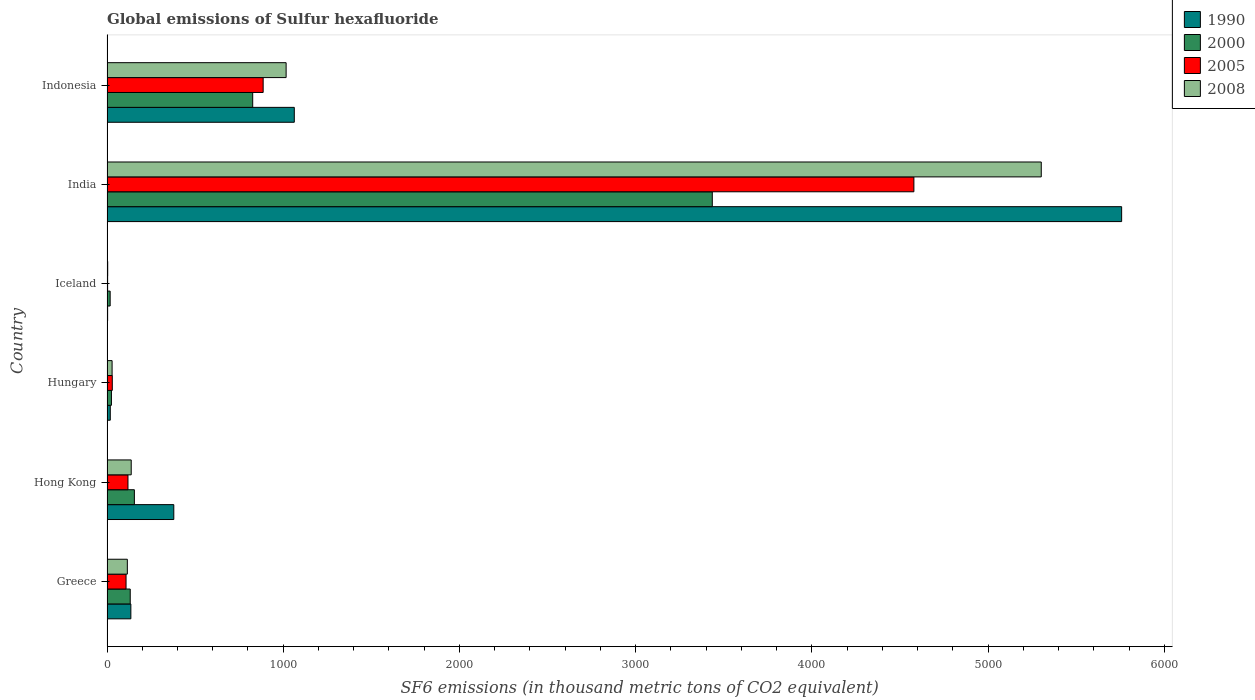How many different coloured bars are there?
Offer a terse response. 4. Are the number of bars on each tick of the Y-axis equal?
Your answer should be very brief. Yes. How many bars are there on the 6th tick from the top?
Your answer should be compact. 4. How many bars are there on the 4th tick from the bottom?
Make the answer very short. 4. What is the label of the 4th group of bars from the top?
Provide a short and direct response. Hungary. In how many cases, is the number of bars for a given country not equal to the number of legend labels?
Offer a very short reply. 0. What is the global emissions of Sulfur hexafluoride in 1990 in Greece?
Offer a very short reply. 135.4. Across all countries, what is the maximum global emissions of Sulfur hexafluoride in 2008?
Make the answer very short. 5301.4. What is the total global emissions of Sulfur hexafluoride in 2000 in the graph?
Provide a short and direct response. 4591.7. What is the difference between the global emissions of Sulfur hexafluoride in 2000 in Greece and that in Hong Kong?
Ensure brevity in your answer.  -23.5. What is the difference between the global emissions of Sulfur hexafluoride in 2000 in Hungary and the global emissions of Sulfur hexafluoride in 2005 in Iceland?
Give a very brief answer. 21.7. What is the average global emissions of Sulfur hexafluoride in 2008 per country?
Your answer should be very brief. 1100.58. What is the difference between the global emissions of Sulfur hexafluoride in 1990 and global emissions of Sulfur hexafluoride in 2008 in Hungary?
Your answer should be compact. -10.3. In how many countries, is the global emissions of Sulfur hexafluoride in 2000 greater than 2200 thousand metric tons?
Your response must be concise. 1. What is the ratio of the global emissions of Sulfur hexafluoride in 2005 in Hungary to that in India?
Keep it short and to the point. 0.01. Is the global emissions of Sulfur hexafluoride in 1990 in Hungary less than that in India?
Offer a terse response. Yes. Is the difference between the global emissions of Sulfur hexafluoride in 1990 in Greece and Hong Kong greater than the difference between the global emissions of Sulfur hexafluoride in 2008 in Greece and Hong Kong?
Offer a very short reply. No. What is the difference between the highest and the second highest global emissions of Sulfur hexafluoride in 2008?
Provide a short and direct response. 4285. What is the difference between the highest and the lowest global emissions of Sulfur hexafluoride in 1990?
Your response must be concise. 5754. Is the sum of the global emissions of Sulfur hexafluoride in 2000 in Greece and India greater than the maximum global emissions of Sulfur hexafluoride in 1990 across all countries?
Your answer should be compact. No. Is it the case that in every country, the sum of the global emissions of Sulfur hexafluoride in 2005 and global emissions of Sulfur hexafluoride in 2000 is greater than the global emissions of Sulfur hexafluoride in 1990?
Offer a very short reply. No. How many bars are there?
Give a very brief answer. 24. Are all the bars in the graph horizontal?
Ensure brevity in your answer.  Yes. Are the values on the major ticks of X-axis written in scientific E-notation?
Keep it short and to the point. No. Where does the legend appear in the graph?
Your answer should be very brief. Top right. How many legend labels are there?
Ensure brevity in your answer.  4. How are the legend labels stacked?
Give a very brief answer. Vertical. What is the title of the graph?
Keep it short and to the point. Global emissions of Sulfur hexafluoride. What is the label or title of the X-axis?
Give a very brief answer. SF6 emissions (in thousand metric tons of CO2 equivalent). What is the SF6 emissions (in thousand metric tons of CO2 equivalent) of 1990 in Greece?
Your answer should be very brief. 135.4. What is the SF6 emissions (in thousand metric tons of CO2 equivalent) in 2000 in Greece?
Ensure brevity in your answer.  131.8. What is the SF6 emissions (in thousand metric tons of CO2 equivalent) of 2005 in Greece?
Provide a short and direct response. 108.1. What is the SF6 emissions (in thousand metric tons of CO2 equivalent) in 2008 in Greece?
Make the answer very short. 115.4. What is the SF6 emissions (in thousand metric tons of CO2 equivalent) of 1990 in Hong Kong?
Keep it short and to the point. 379. What is the SF6 emissions (in thousand metric tons of CO2 equivalent) in 2000 in Hong Kong?
Make the answer very short. 155.3. What is the SF6 emissions (in thousand metric tons of CO2 equivalent) in 2005 in Hong Kong?
Your answer should be compact. 119. What is the SF6 emissions (in thousand metric tons of CO2 equivalent) of 2008 in Hong Kong?
Provide a short and direct response. 137.4. What is the SF6 emissions (in thousand metric tons of CO2 equivalent) of 1990 in Hungary?
Your response must be concise. 18.6. What is the SF6 emissions (in thousand metric tons of CO2 equivalent) of 2000 in Hungary?
Give a very brief answer. 25.2. What is the SF6 emissions (in thousand metric tons of CO2 equivalent) of 2005 in Hungary?
Offer a terse response. 30. What is the SF6 emissions (in thousand metric tons of CO2 equivalent) of 2008 in Hungary?
Your answer should be very brief. 28.9. What is the SF6 emissions (in thousand metric tons of CO2 equivalent) in 1990 in India?
Ensure brevity in your answer.  5757.5. What is the SF6 emissions (in thousand metric tons of CO2 equivalent) of 2000 in India?
Make the answer very short. 3434.7. What is the SF6 emissions (in thousand metric tons of CO2 equivalent) of 2005 in India?
Provide a short and direct response. 4578.7. What is the SF6 emissions (in thousand metric tons of CO2 equivalent) in 2008 in India?
Give a very brief answer. 5301.4. What is the SF6 emissions (in thousand metric tons of CO2 equivalent) in 1990 in Indonesia?
Give a very brief answer. 1062.8. What is the SF6 emissions (in thousand metric tons of CO2 equivalent) in 2000 in Indonesia?
Keep it short and to the point. 826.8. What is the SF6 emissions (in thousand metric tons of CO2 equivalent) in 2005 in Indonesia?
Ensure brevity in your answer.  886.1. What is the SF6 emissions (in thousand metric tons of CO2 equivalent) in 2008 in Indonesia?
Provide a short and direct response. 1016.4. Across all countries, what is the maximum SF6 emissions (in thousand metric tons of CO2 equivalent) of 1990?
Provide a succinct answer. 5757.5. Across all countries, what is the maximum SF6 emissions (in thousand metric tons of CO2 equivalent) of 2000?
Make the answer very short. 3434.7. Across all countries, what is the maximum SF6 emissions (in thousand metric tons of CO2 equivalent) of 2005?
Offer a terse response. 4578.7. Across all countries, what is the maximum SF6 emissions (in thousand metric tons of CO2 equivalent) of 2008?
Provide a succinct answer. 5301.4. Across all countries, what is the minimum SF6 emissions (in thousand metric tons of CO2 equivalent) in 1990?
Offer a terse response. 3.5. Across all countries, what is the minimum SF6 emissions (in thousand metric tons of CO2 equivalent) in 2000?
Offer a terse response. 17.9. Across all countries, what is the minimum SF6 emissions (in thousand metric tons of CO2 equivalent) of 2005?
Make the answer very short. 3.5. What is the total SF6 emissions (in thousand metric tons of CO2 equivalent) of 1990 in the graph?
Provide a short and direct response. 7356.8. What is the total SF6 emissions (in thousand metric tons of CO2 equivalent) in 2000 in the graph?
Your answer should be very brief. 4591.7. What is the total SF6 emissions (in thousand metric tons of CO2 equivalent) in 2005 in the graph?
Offer a terse response. 5725.4. What is the total SF6 emissions (in thousand metric tons of CO2 equivalent) of 2008 in the graph?
Ensure brevity in your answer.  6603.5. What is the difference between the SF6 emissions (in thousand metric tons of CO2 equivalent) in 1990 in Greece and that in Hong Kong?
Make the answer very short. -243.6. What is the difference between the SF6 emissions (in thousand metric tons of CO2 equivalent) in 2000 in Greece and that in Hong Kong?
Ensure brevity in your answer.  -23.5. What is the difference between the SF6 emissions (in thousand metric tons of CO2 equivalent) of 2005 in Greece and that in Hong Kong?
Offer a very short reply. -10.9. What is the difference between the SF6 emissions (in thousand metric tons of CO2 equivalent) in 1990 in Greece and that in Hungary?
Your answer should be compact. 116.8. What is the difference between the SF6 emissions (in thousand metric tons of CO2 equivalent) of 2000 in Greece and that in Hungary?
Provide a short and direct response. 106.6. What is the difference between the SF6 emissions (in thousand metric tons of CO2 equivalent) in 2005 in Greece and that in Hungary?
Your answer should be compact. 78.1. What is the difference between the SF6 emissions (in thousand metric tons of CO2 equivalent) of 2008 in Greece and that in Hungary?
Keep it short and to the point. 86.5. What is the difference between the SF6 emissions (in thousand metric tons of CO2 equivalent) of 1990 in Greece and that in Iceland?
Provide a succinct answer. 131.9. What is the difference between the SF6 emissions (in thousand metric tons of CO2 equivalent) of 2000 in Greece and that in Iceland?
Offer a terse response. 113.9. What is the difference between the SF6 emissions (in thousand metric tons of CO2 equivalent) in 2005 in Greece and that in Iceland?
Ensure brevity in your answer.  104.6. What is the difference between the SF6 emissions (in thousand metric tons of CO2 equivalent) in 2008 in Greece and that in Iceland?
Offer a very short reply. 111.4. What is the difference between the SF6 emissions (in thousand metric tons of CO2 equivalent) in 1990 in Greece and that in India?
Make the answer very short. -5622.1. What is the difference between the SF6 emissions (in thousand metric tons of CO2 equivalent) in 2000 in Greece and that in India?
Your response must be concise. -3302.9. What is the difference between the SF6 emissions (in thousand metric tons of CO2 equivalent) in 2005 in Greece and that in India?
Your answer should be compact. -4470.6. What is the difference between the SF6 emissions (in thousand metric tons of CO2 equivalent) in 2008 in Greece and that in India?
Your answer should be very brief. -5186. What is the difference between the SF6 emissions (in thousand metric tons of CO2 equivalent) of 1990 in Greece and that in Indonesia?
Ensure brevity in your answer.  -927.4. What is the difference between the SF6 emissions (in thousand metric tons of CO2 equivalent) in 2000 in Greece and that in Indonesia?
Your response must be concise. -695. What is the difference between the SF6 emissions (in thousand metric tons of CO2 equivalent) in 2005 in Greece and that in Indonesia?
Make the answer very short. -778. What is the difference between the SF6 emissions (in thousand metric tons of CO2 equivalent) in 2008 in Greece and that in Indonesia?
Ensure brevity in your answer.  -901. What is the difference between the SF6 emissions (in thousand metric tons of CO2 equivalent) of 1990 in Hong Kong and that in Hungary?
Your answer should be compact. 360.4. What is the difference between the SF6 emissions (in thousand metric tons of CO2 equivalent) in 2000 in Hong Kong and that in Hungary?
Offer a very short reply. 130.1. What is the difference between the SF6 emissions (in thousand metric tons of CO2 equivalent) in 2005 in Hong Kong and that in Hungary?
Your answer should be very brief. 89. What is the difference between the SF6 emissions (in thousand metric tons of CO2 equivalent) of 2008 in Hong Kong and that in Hungary?
Your answer should be very brief. 108.5. What is the difference between the SF6 emissions (in thousand metric tons of CO2 equivalent) in 1990 in Hong Kong and that in Iceland?
Offer a terse response. 375.5. What is the difference between the SF6 emissions (in thousand metric tons of CO2 equivalent) of 2000 in Hong Kong and that in Iceland?
Offer a terse response. 137.4. What is the difference between the SF6 emissions (in thousand metric tons of CO2 equivalent) of 2005 in Hong Kong and that in Iceland?
Ensure brevity in your answer.  115.5. What is the difference between the SF6 emissions (in thousand metric tons of CO2 equivalent) in 2008 in Hong Kong and that in Iceland?
Make the answer very short. 133.4. What is the difference between the SF6 emissions (in thousand metric tons of CO2 equivalent) of 1990 in Hong Kong and that in India?
Your answer should be compact. -5378.5. What is the difference between the SF6 emissions (in thousand metric tons of CO2 equivalent) of 2000 in Hong Kong and that in India?
Make the answer very short. -3279.4. What is the difference between the SF6 emissions (in thousand metric tons of CO2 equivalent) in 2005 in Hong Kong and that in India?
Your answer should be compact. -4459.7. What is the difference between the SF6 emissions (in thousand metric tons of CO2 equivalent) of 2008 in Hong Kong and that in India?
Give a very brief answer. -5164. What is the difference between the SF6 emissions (in thousand metric tons of CO2 equivalent) of 1990 in Hong Kong and that in Indonesia?
Your response must be concise. -683.8. What is the difference between the SF6 emissions (in thousand metric tons of CO2 equivalent) in 2000 in Hong Kong and that in Indonesia?
Provide a succinct answer. -671.5. What is the difference between the SF6 emissions (in thousand metric tons of CO2 equivalent) of 2005 in Hong Kong and that in Indonesia?
Ensure brevity in your answer.  -767.1. What is the difference between the SF6 emissions (in thousand metric tons of CO2 equivalent) in 2008 in Hong Kong and that in Indonesia?
Provide a short and direct response. -879. What is the difference between the SF6 emissions (in thousand metric tons of CO2 equivalent) in 2000 in Hungary and that in Iceland?
Ensure brevity in your answer.  7.3. What is the difference between the SF6 emissions (in thousand metric tons of CO2 equivalent) of 2005 in Hungary and that in Iceland?
Make the answer very short. 26.5. What is the difference between the SF6 emissions (in thousand metric tons of CO2 equivalent) in 2008 in Hungary and that in Iceland?
Offer a terse response. 24.9. What is the difference between the SF6 emissions (in thousand metric tons of CO2 equivalent) in 1990 in Hungary and that in India?
Make the answer very short. -5738.9. What is the difference between the SF6 emissions (in thousand metric tons of CO2 equivalent) in 2000 in Hungary and that in India?
Keep it short and to the point. -3409.5. What is the difference between the SF6 emissions (in thousand metric tons of CO2 equivalent) in 2005 in Hungary and that in India?
Your answer should be compact. -4548.7. What is the difference between the SF6 emissions (in thousand metric tons of CO2 equivalent) of 2008 in Hungary and that in India?
Your answer should be very brief. -5272.5. What is the difference between the SF6 emissions (in thousand metric tons of CO2 equivalent) in 1990 in Hungary and that in Indonesia?
Your response must be concise. -1044.2. What is the difference between the SF6 emissions (in thousand metric tons of CO2 equivalent) in 2000 in Hungary and that in Indonesia?
Your answer should be compact. -801.6. What is the difference between the SF6 emissions (in thousand metric tons of CO2 equivalent) of 2005 in Hungary and that in Indonesia?
Keep it short and to the point. -856.1. What is the difference between the SF6 emissions (in thousand metric tons of CO2 equivalent) in 2008 in Hungary and that in Indonesia?
Keep it short and to the point. -987.5. What is the difference between the SF6 emissions (in thousand metric tons of CO2 equivalent) in 1990 in Iceland and that in India?
Keep it short and to the point. -5754. What is the difference between the SF6 emissions (in thousand metric tons of CO2 equivalent) of 2000 in Iceland and that in India?
Provide a succinct answer. -3416.8. What is the difference between the SF6 emissions (in thousand metric tons of CO2 equivalent) of 2005 in Iceland and that in India?
Offer a very short reply. -4575.2. What is the difference between the SF6 emissions (in thousand metric tons of CO2 equivalent) in 2008 in Iceland and that in India?
Keep it short and to the point. -5297.4. What is the difference between the SF6 emissions (in thousand metric tons of CO2 equivalent) in 1990 in Iceland and that in Indonesia?
Keep it short and to the point. -1059.3. What is the difference between the SF6 emissions (in thousand metric tons of CO2 equivalent) in 2000 in Iceland and that in Indonesia?
Keep it short and to the point. -808.9. What is the difference between the SF6 emissions (in thousand metric tons of CO2 equivalent) of 2005 in Iceland and that in Indonesia?
Offer a terse response. -882.6. What is the difference between the SF6 emissions (in thousand metric tons of CO2 equivalent) of 2008 in Iceland and that in Indonesia?
Your answer should be very brief. -1012.4. What is the difference between the SF6 emissions (in thousand metric tons of CO2 equivalent) in 1990 in India and that in Indonesia?
Keep it short and to the point. 4694.7. What is the difference between the SF6 emissions (in thousand metric tons of CO2 equivalent) of 2000 in India and that in Indonesia?
Offer a very short reply. 2607.9. What is the difference between the SF6 emissions (in thousand metric tons of CO2 equivalent) of 2005 in India and that in Indonesia?
Make the answer very short. 3692.6. What is the difference between the SF6 emissions (in thousand metric tons of CO2 equivalent) in 2008 in India and that in Indonesia?
Offer a very short reply. 4285. What is the difference between the SF6 emissions (in thousand metric tons of CO2 equivalent) in 1990 in Greece and the SF6 emissions (in thousand metric tons of CO2 equivalent) in 2000 in Hong Kong?
Keep it short and to the point. -19.9. What is the difference between the SF6 emissions (in thousand metric tons of CO2 equivalent) in 1990 in Greece and the SF6 emissions (in thousand metric tons of CO2 equivalent) in 2008 in Hong Kong?
Make the answer very short. -2. What is the difference between the SF6 emissions (in thousand metric tons of CO2 equivalent) of 2000 in Greece and the SF6 emissions (in thousand metric tons of CO2 equivalent) of 2005 in Hong Kong?
Your answer should be compact. 12.8. What is the difference between the SF6 emissions (in thousand metric tons of CO2 equivalent) of 2000 in Greece and the SF6 emissions (in thousand metric tons of CO2 equivalent) of 2008 in Hong Kong?
Provide a succinct answer. -5.6. What is the difference between the SF6 emissions (in thousand metric tons of CO2 equivalent) in 2005 in Greece and the SF6 emissions (in thousand metric tons of CO2 equivalent) in 2008 in Hong Kong?
Your answer should be compact. -29.3. What is the difference between the SF6 emissions (in thousand metric tons of CO2 equivalent) of 1990 in Greece and the SF6 emissions (in thousand metric tons of CO2 equivalent) of 2000 in Hungary?
Offer a terse response. 110.2. What is the difference between the SF6 emissions (in thousand metric tons of CO2 equivalent) in 1990 in Greece and the SF6 emissions (in thousand metric tons of CO2 equivalent) in 2005 in Hungary?
Offer a terse response. 105.4. What is the difference between the SF6 emissions (in thousand metric tons of CO2 equivalent) in 1990 in Greece and the SF6 emissions (in thousand metric tons of CO2 equivalent) in 2008 in Hungary?
Provide a short and direct response. 106.5. What is the difference between the SF6 emissions (in thousand metric tons of CO2 equivalent) of 2000 in Greece and the SF6 emissions (in thousand metric tons of CO2 equivalent) of 2005 in Hungary?
Keep it short and to the point. 101.8. What is the difference between the SF6 emissions (in thousand metric tons of CO2 equivalent) in 2000 in Greece and the SF6 emissions (in thousand metric tons of CO2 equivalent) in 2008 in Hungary?
Ensure brevity in your answer.  102.9. What is the difference between the SF6 emissions (in thousand metric tons of CO2 equivalent) of 2005 in Greece and the SF6 emissions (in thousand metric tons of CO2 equivalent) of 2008 in Hungary?
Make the answer very short. 79.2. What is the difference between the SF6 emissions (in thousand metric tons of CO2 equivalent) in 1990 in Greece and the SF6 emissions (in thousand metric tons of CO2 equivalent) in 2000 in Iceland?
Your answer should be very brief. 117.5. What is the difference between the SF6 emissions (in thousand metric tons of CO2 equivalent) in 1990 in Greece and the SF6 emissions (in thousand metric tons of CO2 equivalent) in 2005 in Iceland?
Offer a very short reply. 131.9. What is the difference between the SF6 emissions (in thousand metric tons of CO2 equivalent) of 1990 in Greece and the SF6 emissions (in thousand metric tons of CO2 equivalent) of 2008 in Iceland?
Your answer should be very brief. 131.4. What is the difference between the SF6 emissions (in thousand metric tons of CO2 equivalent) of 2000 in Greece and the SF6 emissions (in thousand metric tons of CO2 equivalent) of 2005 in Iceland?
Your response must be concise. 128.3. What is the difference between the SF6 emissions (in thousand metric tons of CO2 equivalent) of 2000 in Greece and the SF6 emissions (in thousand metric tons of CO2 equivalent) of 2008 in Iceland?
Your response must be concise. 127.8. What is the difference between the SF6 emissions (in thousand metric tons of CO2 equivalent) in 2005 in Greece and the SF6 emissions (in thousand metric tons of CO2 equivalent) in 2008 in Iceland?
Your response must be concise. 104.1. What is the difference between the SF6 emissions (in thousand metric tons of CO2 equivalent) of 1990 in Greece and the SF6 emissions (in thousand metric tons of CO2 equivalent) of 2000 in India?
Your response must be concise. -3299.3. What is the difference between the SF6 emissions (in thousand metric tons of CO2 equivalent) in 1990 in Greece and the SF6 emissions (in thousand metric tons of CO2 equivalent) in 2005 in India?
Keep it short and to the point. -4443.3. What is the difference between the SF6 emissions (in thousand metric tons of CO2 equivalent) of 1990 in Greece and the SF6 emissions (in thousand metric tons of CO2 equivalent) of 2008 in India?
Your answer should be compact. -5166. What is the difference between the SF6 emissions (in thousand metric tons of CO2 equivalent) of 2000 in Greece and the SF6 emissions (in thousand metric tons of CO2 equivalent) of 2005 in India?
Your response must be concise. -4446.9. What is the difference between the SF6 emissions (in thousand metric tons of CO2 equivalent) of 2000 in Greece and the SF6 emissions (in thousand metric tons of CO2 equivalent) of 2008 in India?
Keep it short and to the point. -5169.6. What is the difference between the SF6 emissions (in thousand metric tons of CO2 equivalent) of 2005 in Greece and the SF6 emissions (in thousand metric tons of CO2 equivalent) of 2008 in India?
Give a very brief answer. -5193.3. What is the difference between the SF6 emissions (in thousand metric tons of CO2 equivalent) of 1990 in Greece and the SF6 emissions (in thousand metric tons of CO2 equivalent) of 2000 in Indonesia?
Ensure brevity in your answer.  -691.4. What is the difference between the SF6 emissions (in thousand metric tons of CO2 equivalent) in 1990 in Greece and the SF6 emissions (in thousand metric tons of CO2 equivalent) in 2005 in Indonesia?
Give a very brief answer. -750.7. What is the difference between the SF6 emissions (in thousand metric tons of CO2 equivalent) in 1990 in Greece and the SF6 emissions (in thousand metric tons of CO2 equivalent) in 2008 in Indonesia?
Your answer should be very brief. -881. What is the difference between the SF6 emissions (in thousand metric tons of CO2 equivalent) of 2000 in Greece and the SF6 emissions (in thousand metric tons of CO2 equivalent) of 2005 in Indonesia?
Keep it short and to the point. -754.3. What is the difference between the SF6 emissions (in thousand metric tons of CO2 equivalent) in 2000 in Greece and the SF6 emissions (in thousand metric tons of CO2 equivalent) in 2008 in Indonesia?
Your answer should be very brief. -884.6. What is the difference between the SF6 emissions (in thousand metric tons of CO2 equivalent) of 2005 in Greece and the SF6 emissions (in thousand metric tons of CO2 equivalent) of 2008 in Indonesia?
Offer a terse response. -908.3. What is the difference between the SF6 emissions (in thousand metric tons of CO2 equivalent) of 1990 in Hong Kong and the SF6 emissions (in thousand metric tons of CO2 equivalent) of 2000 in Hungary?
Give a very brief answer. 353.8. What is the difference between the SF6 emissions (in thousand metric tons of CO2 equivalent) in 1990 in Hong Kong and the SF6 emissions (in thousand metric tons of CO2 equivalent) in 2005 in Hungary?
Your answer should be compact. 349. What is the difference between the SF6 emissions (in thousand metric tons of CO2 equivalent) of 1990 in Hong Kong and the SF6 emissions (in thousand metric tons of CO2 equivalent) of 2008 in Hungary?
Your answer should be compact. 350.1. What is the difference between the SF6 emissions (in thousand metric tons of CO2 equivalent) of 2000 in Hong Kong and the SF6 emissions (in thousand metric tons of CO2 equivalent) of 2005 in Hungary?
Give a very brief answer. 125.3. What is the difference between the SF6 emissions (in thousand metric tons of CO2 equivalent) of 2000 in Hong Kong and the SF6 emissions (in thousand metric tons of CO2 equivalent) of 2008 in Hungary?
Keep it short and to the point. 126.4. What is the difference between the SF6 emissions (in thousand metric tons of CO2 equivalent) of 2005 in Hong Kong and the SF6 emissions (in thousand metric tons of CO2 equivalent) of 2008 in Hungary?
Give a very brief answer. 90.1. What is the difference between the SF6 emissions (in thousand metric tons of CO2 equivalent) in 1990 in Hong Kong and the SF6 emissions (in thousand metric tons of CO2 equivalent) in 2000 in Iceland?
Provide a succinct answer. 361.1. What is the difference between the SF6 emissions (in thousand metric tons of CO2 equivalent) in 1990 in Hong Kong and the SF6 emissions (in thousand metric tons of CO2 equivalent) in 2005 in Iceland?
Ensure brevity in your answer.  375.5. What is the difference between the SF6 emissions (in thousand metric tons of CO2 equivalent) of 1990 in Hong Kong and the SF6 emissions (in thousand metric tons of CO2 equivalent) of 2008 in Iceland?
Your answer should be compact. 375. What is the difference between the SF6 emissions (in thousand metric tons of CO2 equivalent) in 2000 in Hong Kong and the SF6 emissions (in thousand metric tons of CO2 equivalent) in 2005 in Iceland?
Provide a short and direct response. 151.8. What is the difference between the SF6 emissions (in thousand metric tons of CO2 equivalent) in 2000 in Hong Kong and the SF6 emissions (in thousand metric tons of CO2 equivalent) in 2008 in Iceland?
Provide a short and direct response. 151.3. What is the difference between the SF6 emissions (in thousand metric tons of CO2 equivalent) in 2005 in Hong Kong and the SF6 emissions (in thousand metric tons of CO2 equivalent) in 2008 in Iceland?
Your answer should be very brief. 115. What is the difference between the SF6 emissions (in thousand metric tons of CO2 equivalent) of 1990 in Hong Kong and the SF6 emissions (in thousand metric tons of CO2 equivalent) of 2000 in India?
Keep it short and to the point. -3055.7. What is the difference between the SF6 emissions (in thousand metric tons of CO2 equivalent) of 1990 in Hong Kong and the SF6 emissions (in thousand metric tons of CO2 equivalent) of 2005 in India?
Keep it short and to the point. -4199.7. What is the difference between the SF6 emissions (in thousand metric tons of CO2 equivalent) of 1990 in Hong Kong and the SF6 emissions (in thousand metric tons of CO2 equivalent) of 2008 in India?
Ensure brevity in your answer.  -4922.4. What is the difference between the SF6 emissions (in thousand metric tons of CO2 equivalent) of 2000 in Hong Kong and the SF6 emissions (in thousand metric tons of CO2 equivalent) of 2005 in India?
Your answer should be very brief. -4423.4. What is the difference between the SF6 emissions (in thousand metric tons of CO2 equivalent) of 2000 in Hong Kong and the SF6 emissions (in thousand metric tons of CO2 equivalent) of 2008 in India?
Provide a succinct answer. -5146.1. What is the difference between the SF6 emissions (in thousand metric tons of CO2 equivalent) of 2005 in Hong Kong and the SF6 emissions (in thousand metric tons of CO2 equivalent) of 2008 in India?
Offer a very short reply. -5182.4. What is the difference between the SF6 emissions (in thousand metric tons of CO2 equivalent) of 1990 in Hong Kong and the SF6 emissions (in thousand metric tons of CO2 equivalent) of 2000 in Indonesia?
Give a very brief answer. -447.8. What is the difference between the SF6 emissions (in thousand metric tons of CO2 equivalent) in 1990 in Hong Kong and the SF6 emissions (in thousand metric tons of CO2 equivalent) in 2005 in Indonesia?
Give a very brief answer. -507.1. What is the difference between the SF6 emissions (in thousand metric tons of CO2 equivalent) in 1990 in Hong Kong and the SF6 emissions (in thousand metric tons of CO2 equivalent) in 2008 in Indonesia?
Offer a terse response. -637.4. What is the difference between the SF6 emissions (in thousand metric tons of CO2 equivalent) of 2000 in Hong Kong and the SF6 emissions (in thousand metric tons of CO2 equivalent) of 2005 in Indonesia?
Offer a terse response. -730.8. What is the difference between the SF6 emissions (in thousand metric tons of CO2 equivalent) in 2000 in Hong Kong and the SF6 emissions (in thousand metric tons of CO2 equivalent) in 2008 in Indonesia?
Provide a succinct answer. -861.1. What is the difference between the SF6 emissions (in thousand metric tons of CO2 equivalent) of 2005 in Hong Kong and the SF6 emissions (in thousand metric tons of CO2 equivalent) of 2008 in Indonesia?
Your answer should be very brief. -897.4. What is the difference between the SF6 emissions (in thousand metric tons of CO2 equivalent) in 1990 in Hungary and the SF6 emissions (in thousand metric tons of CO2 equivalent) in 2005 in Iceland?
Offer a very short reply. 15.1. What is the difference between the SF6 emissions (in thousand metric tons of CO2 equivalent) in 2000 in Hungary and the SF6 emissions (in thousand metric tons of CO2 equivalent) in 2005 in Iceland?
Offer a terse response. 21.7. What is the difference between the SF6 emissions (in thousand metric tons of CO2 equivalent) in 2000 in Hungary and the SF6 emissions (in thousand metric tons of CO2 equivalent) in 2008 in Iceland?
Your answer should be compact. 21.2. What is the difference between the SF6 emissions (in thousand metric tons of CO2 equivalent) of 1990 in Hungary and the SF6 emissions (in thousand metric tons of CO2 equivalent) of 2000 in India?
Ensure brevity in your answer.  -3416.1. What is the difference between the SF6 emissions (in thousand metric tons of CO2 equivalent) in 1990 in Hungary and the SF6 emissions (in thousand metric tons of CO2 equivalent) in 2005 in India?
Your answer should be compact. -4560.1. What is the difference between the SF6 emissions (in thousand metric tons of CO2 equivalent) in 1990 in Hungary and the SF6 emissions (in thousand metric tons of CO2 equivalent) in 2008 in India?
Offer a very short reply. -5282.8. What is the difference between the SF6 emissions (in thousand metric tons of CO2 equivalent) in 2000 in Hungary and the SF6 emissions (in thousand metric tons of CO2 equivalent) in 2005 in India?
Provide a succinct answer. -4553.5. What is the difference between the SF6 emissions (in thousand metric tons of CO2 equivalent) of 2000 in Hungary and the SF6 emissions (in thousand metric tons of CO2 equivalent) of 2008 in India?
Keep it short and to the point. -5276.2. What is the difference between the SF6 emissions (in thousand metric tons of CO2 equivalent) of 2005 in Hungary and the SF6 emissions (in thousand metric tons of CO2 equivalent) of 2008 in India?
Offer a terse response. -5271.4. What is the difference between the SF6 emissions (in thousand metric tons of CO2 equivalent) in 1990 in Hungary and the SF6 emissions (in thousand metric tons of CO2 equivalent) in 2000 in Indonesia?
Keep it short and to the point. -808.2. What is the difference between the SF6 emissions (in thousand metric tons of CO2 equivalent) of 1990 in Hungary and the SF6 emissions (in thousand metric tons of CO2 equivalent) of 2005 in Indonesia?
Your response must be concise. -867.5. What is the difference between the SF6 emissions (in thousand metric tons of CO2 equivalent) of 1990 in Hungary and the SF6 emissions (in thousand metric tons of CO2 equivalent) of 2008 in Indonesia?
Offer a very short reply. -997.8. What is the difference between the SF6 emissions (in thousand metric tons of CO2 equivalent) in 2000 in Hungary and the SF6 emissions (in thousand metric tons of CO2 equivalent) in 2005 in Indonesia?
Your answer should be very brief. -860.9. What is the difference between the SF6 emissions (in thousand metric tons of CO2 equivalent) of 2000 in Hungary and the SF6 emissions (in thousand metric tons of CO2 equivalent) of 2008 in Indonesia?
Your answer should be very brief. -991.2. What is the difference between the SF6 emissions (in thousand metric tons of CO2 equivalent) in 2005 in Hungary and the SF6 emissions (in thousand metric tons of CO2 equivalent) in 2008 in Indonesia?
Offer a terse response. -986.4. What is the difference between the SF6 emissions (in thousand metric tons of CO2 equivalent) in 1990 in Iceland and the SF6 emissions (in thousand metric tons of CO2 equivalent) in 2000 in India?
Make the answer very short. -3431.2. What is the difference between the SF6 emissions (in thousand metric tons of CO2 equivalent) in 1990 in Iceland and the SF6 emissions (in thousand metric tons of CO2 equivalent) in 2005 in India?
Ensure brevity in your answer.  -4575.2. What is the difference between the SF6 emissions (in thousand metric tons of CO2 equivalent) in 1990 in Iceland and the SF6 emissions (in thousand metric tons of CO2 equivalent) in 2008 in India?
Your answer should be very brief. -5297.9. What is the difference between the SF6 emissions (in thousand metric tons of CO2 equivalent) in 2000 in Iceland and the SF6 emissions (in thousand metric tons of CO2 equivalent) in 2005 in India?
Provide a short and direct response. -4560.8. What is the difference between the SF6 emissions (in thousand metric tons of CO2 equivalent) of 2000 in Iceland and the SF6 emissions (in thousand metric tons of CO2 equivalent) of 2008 in India?
Offer a terse response. -5283.5. What is the difference between the SF6 emissions (in thousand metric tons of CO2 equivalent) of 2005 in Iceland and the SF6 emissions (in thousand metric tons of CO2 equivalent) of 2008 in India?
Ensure brevity in your answer.  -5297.9. What is the difference between the SF6 emissions (in thousand metric tons of CO2 equivalent) in 1990 in Iceland and the SF6 emissions (in thousand metric tons of CO2 equivalent) in 2000 in Indonesia?
Provide a succinct answer. -823.3. What is the difference between the SF6 emissions (in thousand metric tons of CO2 equivalent) in 1990 in Iceland and the SF6 emissions (in thousand metric tons of CO2 equivalent) in 2005 in Indonesia?
Offer a terse response. -882.6. What is the difference between the SF6 emissions (in thousand metric tons of CO2 equivalent) in 1990 in Iceland and the SF6 emissions (in thousand metric tons of CO2 equivalent) in 2008 in Indonesia?
Provide a short and direct response. -1012.9. What is the difference between the SF6 emissions (in thousand metric tons of CO2 equivalent) of 2000 in Iceland and the SF6 emissions (in thousand metric tons of CO2 equivalent) of 2005 in Indonesia?
Your answer should be very brief. -868.2. What is the difference between the SF6 emissions (in thousand metric tons of CO2 equivalent) of 2000 in Iceland and the SF6 emissions (in thousand metric tons of CO2 equivalent) of 2008 in Indonesia?
Make the answer very short. -998.5. What is the difference between the SF6 emissions (in thousand metric tons of CO2 equivalent) in 2005 in Iceland and the SF6 emissions (in thousand metric tons of CO2 equivalent) in 2008 in Indonesia?
Your response must be concise. -1012.9. What is the difference between the SF6 emissions (in thousand metric tons of CO2 equivalent) of 1990 in India and the SF6 emissions (in thousand metric tons of CO2 equivalent) of 2000 in Indonesia?
Make the answer very short. 4930.7. What is the difference between the SF6 emissions (in thousand metric tons of CO2 equivalent) in 1990 in India and the SF6 emissions (in thousand metric tons of CO2 equivalent) in 2005 in Indonesia?
Provide a short and direct response. 4871.4. What is the difference between the SF6 emissions (in thousand metric tons of CO2 equivalent) in 1990 in India and the SF6 emissions (in thousand metric tons of CO2 equivalent) in 2008 in Indonesia?
Give a very brief answer. 4741.1. What is the difference between the SF6 emissions (in thousand metric tons of CO2 equivalent) of 2000 in India and the SF6 emissions (in thousand metric tons of CO2 equivalent) of 2005 in Indonesia?
Ensure brevity in your answer.  2548.6. What is the difference between the SF6 emissions (in thousand metric tons of CO2 equivalent) of 2000 in India and the SF6 emissions (in thousand metric tons of CO2 equivalent) of 2008 in Indonesia?
Offer a very short reply. 2418.3. What is the difference between the SF6 emissions (in thousand metric tons of CO2 equivalent) in 2005 in India and the SF6 emissions (in thousand metric tons of CO2 equivalent) in 2008 in Indonesia?
Provide a short and direct response. 3562.3. What is the average SF6 emissions (in thousand metric tons of CO2 equivalent) in 1990 per country?
Ensure brevity in your answer.  1226.13. What is the average SF6 emissions (in thousand metric tons of CO2 equivalent) of 2000 per country?
Make the answer very short. 765.28. What is the average SF6 emissions (in thousand metric tons of CO2 equivalent) of 2005 per country?
Give a very brief answer. 954.23. What is the average SF6 emissions (in thousand metric tons of CO2 equivalent) of 2008 per country?
Provide a succinct answer. 1100.58. What is the difference between the SF6 emissions (in thousand metric tons of CO2 equivalent) of 1990 and SF6 emissions (in thousand metric tons of CO2 equivalent) of 2005 in Greece?
Provide a succinct answer. 27.3. What is the difference between the SF6 emissions (in thousand metric tons of CO2 equivalent) in 1990 and SF6 emissions (in thousand metric tons of CO2 equivalent) in 2008 in Greece?
Your response must be concise. 20. What is the difference between the SF6 emissions (in thousand metric tons of CO2 equivalent) in 2000 and SF6 emissions (in thousand metric tons of CO2 equivalent) in 2005 in Greece?
Your answer should be compact. 23.7. What is the difference between the SF6 emissions (in thousand metric tons of CO2 equivalent) of 2000 and SF6 emissions (in thousand metric tons of CO2 equivalent) of 2008 in Greece?
Make the answer very short. 16.4. What is the difference between the SF6 emissions (in thousand metric tons of CO2 equivalent) of 1990 and SF6 emissions (in thousand metric tons of CO2 equivalent) of 2000 in Hong Kong?
Provide a succinct answer. 223.7. What is the difference between the SF6 emissions (in thousand metric tons of CO2 equivalent) of 1990 and SF6 emissions (in thousand metric tons of CO2 equivalent) of 2005 in Hong Kong?
Keep it short and to the point. 260. What is the difference between the SF6 emissions (in thousand metric tons of CO2 equivalent) in 1990 and SF6 emissions (in thousand metric tons of CO2 equivalent) in 2008 in Hong Kong?
Provide a short and direct response. 241.6. What is the difference between the SF6 emissions (in thousand metric tons of CO2 equivalent) of 2000 and SF6 emissions (in thousand metric tons of CO2 equivalent) of 2005 in Hong Kong?
Ensure brevity in your answer.  36.3. What is the difference between the SF6 emissions (in thousand metric tons of CO2 equivalent) in 2005 and SF6 emissions (in thousand metric tons of CO2 equivalent) in 2008 in Hong Kong?
Your answer should be very brief. -18.4. What is the difference between the SF6 emissions (in thousand metric tons of CO2 equivalent) in 2000 and SF6 emissions (in thousand metric tons of CO2 equivalent) in 2008 in Hungary?
Your answer should be compact. -3.7. What is the difference between the SF6 emissions (in thousand metric tons of CO2 equivalent) of 1990 and SF6 emissions (in thousand metric tons of CO2 equivalent) of 2000 in Iceland?
Provide a succinct answer. -14.4. What is the difference between the SF6 emissions (in thousand metric tons of CO2 equivalent) in 2005 and SF6 emissions (in thousand metric tons of CO2 equivalent) in 2008 in Iceland?
Give a very brief answer. -0.5. What is the difference between the SF6 emissions (in thousand metric tons of CO2 equivalent) of 1990 and SF6 emissions (in thousand metric tons of CO2 equivalent) of 2000 in India?
Make the answer very short. 2322.8. What is the difference between the SF6 emissions (in thousand metric tons of CO2 equivalent) of 1990 and SF6 emissions (in thousand metric tons of CO2 equivalent) of 2005 in India?
Provide a succinct answer. 1178.8. What is the difference between the SF6 emissions (in thousand metric tons of CO2 equivalent) of 1990 and SF6 emissions (in thousand metric tons of CO2 equivalent) of 2008 in India?
Offer a terse response. 456.1. What is the difference between the SF6 emissions (in thousand metric tons of CO2 equivalent) in 2000 and SF6 emissions (in thousand metric tons of CO2 equivalent) in 2005 in India?
Give a very brief answer. -1144. What is the difference between the SF6 emissions (in thousand metric tons of CO2 equivalent) in 2000 and SF6 emissions (in thousand metric tons of CO2 equivalent) in 2008 in India?
Keep it short and to the point. -1866.7. What is the difference between the SF6 emissions (in thousand metric tons of CO2 equivalent) in 2005 and SF6 emissions (in thousand metric tons of CO2 equivalent) in 2008 in India?
Provide a succinct answer. -722.7. What is the difference between the SF6 emissions (in thousand metric tons of CO2 equivalent) in 1990 and SF6 emissions (in thousand metric tons of CO2 equivalent) in 2000 in Indonesia?
Offer a terse response. 236. What is the difference between the SF6 emissions (in thousand metric tons of CO2 equivalent) in 1990 and SF6 emissions (in thousand metric tons of CO2 equivalent) in 2005 in Indonesia?
Your answer should be very brief. 176.7. What is the difference between the SF6 emissions (in thousand metric tons of CO2 equivalent) in 1990 and SF6 emissions (in thousand metric tons of CO2 equivalent) in 2008 in Indonesia?
Offer a terse response. 46.4. What is the difference between the SF6 emissions (in thousand metric tons of CO2 equivalent) in 2000 and SF6 emissions (in thousand metric tons of CO2 equivalent) in 2005 in Indonesia?
Your answer should be very brief. -59.3. What is the difference between the SF6 emissions (in thousand metric tons of CO2 equivalent) of 2000 and SF6 emissions (in thousand metric tons of CO2 equivalent) of 2008 in Indonesia?
Your answer should be compact. -189.6. What is the difference between the SF6 emissions (in thousand metric tons of CO2 equivalent) in 2005 and SF6 emissions (in thousand metric tons of CO2 equivalent) in 2008 in Indonesia?
Keep it short and to the point. -130.3. What is the ratio of the SF6 emissions (in thousand metric tons of CO2 equivalent) of 1990 in Greece to that in Hong Kong?
Offer a very short reply. 0.36. What is the ratio of the SF6 emissions (in thousand metric tons of CO2 equivalent) of 2000 in Greece to that in Hong Kong?
Provide a short and direct response. 0.85. What is the ratio of the SF6 emissions (in thousand metric tons of CO2 equivalent) in 2005 in Greece to that in Hong Kong?
Your response must be concise. 0.91. What is the ratio of the SF6 emissions (in thousand metric tons of CO2 equivalent) in 2008 in Greece to that in Hong Kong?
Your answer should be compact. 0.84. What is the ratio of the SF6 emissions (in thousand metric tons of CO2 equivalent) in 1990 in Greece to that in Hungary?
Make the answer very short. 7.28. What is the ratio of the SF6 emissions (in thousand metric tons of CO2 equivalent) in 2000 in Greece to that in Hungary?
Make the answer very short. 5.23. What is the ratio of the SF6 emissions (in thousand metric tons of CO2 equivalent) in 2005 in Greece to that in Hungary?
Offer a terse response. 3.6. What is the ratio of the SF6 emissions (in thousand metric tons of CO2 equivalent) in 2008 in Greece to that in Hungary?
Your response must be concise. 3.99. What is the ratio of the SF6 emissions (in thousand metric tons of CO2 equivalent) of 1990 in Greece to that in Iceland?
Offer a terse response. 38.69. What is the ratio of the SF6 emissions (in thousand metric tons of CO2 equivalent) of 2000 in Greece to that in Iceland?
Provide a succinct answer. 7.36. What is the ratio of the SF6 emissions (in thousand metric tons of CO2 equivalent) of 2005 in Greece to that in Iceland?
Your response must be concise. 30.89. What is the ratio of the SF6 emissions (in thousand metric tons of CO2 equivalent) of 2008 in Greece to that in Iceland?
Your response must be concise. 28.85. What is the ratio of the SF6 emissions (in thousand metric tons of CO2 equivalent) in 1990 in Greece to that in India?
Give a very brief answer. 0.02. What is the ratio of the SF6 emissions (in thousand metric tons of CO2 equivalent) of 2000 in Greece to that in India?
Make the answer very short. 0.04. What is the ratio of the SF6 emissions (in thousand metric tons of CO2 equivalent) of 2005 in Greece to that in India?
Give a very brief answer. 0.02. What is the ratio of the SF6 emissions (in thousand metric tons of CO2 equivalent) in 2008 in Greece to that in India?
Give a very brief answer. 0.02. What is the ratio of the SF6 emissions (in thousand metric tons of CO2 equivalent) of 1990 in Greece to that in Indonesia?
Give a very brief answer. 0.13. What is the ratio of the SF6 emissions (in thousand metric tons of CO2 equivalent) of 2000 in Greece to that in Indonesia?
Offer a terse response. 0.16. What is the ratio of the SF6 emissions (in thousand metric tons of CO2 equivalent) of 2005 in Greece to that in Indonesia?
Offer a terse response. 0.12. What is the ratio of the SF6 emissions (in thousand metric tons of CO2 equivalent) of 2008 in Greece to that in Indonesia?
Offer a very short reply. 0.11. What is the ratio of the SF6 emissions (in thousand metric tons of CO2 equivalent) of 1990 in Hong Kong to that in Hungary?
Keep it short and to the point. 20.38. What is the ratio of the SF6 emissions (in thousand metric tons of CO2 equivalent) of 2000 in Hong Kong to that in Hungary?
Provide a succinct answer. 6.16. What is the ratio of the SF6 emissions (in thousand metric tons of CO2 equivalent) in 2005 in Hong Kong to that in Hungary?
Ensure brevity in your answer.  3.97. What is the ratio of the SF6 emissions (in thousand metric tons of CO2 equivalent) of 2008 in Hong Kong to that in Hungary?
Make the answer very short. 4.75. What is the ratio of the SF6 emissions (in thousand metric tons of CO2 equivalent) in 1990 in Hong Kong to that in Iceland?
Your answer should be compact. 108.29. What is the ratio of the SF6 emissions (in thousand metric tons of CO2 equivalent) of 2000 in Hong Kong to that in Iceland?
Your answer should be compact. 8.68. What is the ratio of the SF6 emissions (in thousand metric tons of CO2 equivalent) of 2005 in Hong Kong to that in Iceland?
Provide a short and direct response. 34. What is the ratio of the SF6 emissions (in thousand metric tons of CO2 equivalent) in 2008 in Hong Kong to that in Iceland?
Your answer should be compact. 34.35. What is the ratio of the SF6 emissions (in thousand metric tons of CO2 equivalent) in 1990 in Hong Kong to that in India?
Your response must be concise. 0.07. What is the ratio of the SF6 emissions (in thousand metric tons of CO2 equivalent) of 2000 in Hong Kong to that in India?
Your response must be concise. 0.05. What is the ratio of the SF6 emissions (in thousand metric tons of CO2 equivalent) of 2005 in Hong Kong to that in India?
Offer a terse response. 0.03. What is the ratio of the SF6 emissions (in thousand metric tons of CO2 equivalent) in 2008 in Hong Kong to that in India?
Ensure brevity in your answer.  0.03. What is the ratio of the SF6 emissions (in thousand metric tons of CO2 equivalent) of 1990 in Hong Kong to that in Indonesia?
Ensure brevity in your answer.  0.36. What is the ratio of the SF6 emissions (in thousand metric tons of CO2 equivalent) in 2000 in Hong Kong to that in Indonesia?
Keep it short and to the point. 0.19. What is the ratio of the SF6 emissions (in thousand metric tons of CO2 equivalent) in 2005 in Hong Kong to that in Indonesia?
Ensure brevity in your answer.  0.13. What is the ratio of the SF6 emissions (in thousand metric tons of CO2 equivalent) of 2008 in Hong Kong to that in Indonesia?
Offer a terse response. 0.14. What is the ratio of the SF6 emissions (in thousand metric tons of CO2 equivalent) of 1990 in Hungary to that in Iceland?
Keep it short and to the point. 5.31. What is the ratio of the SF6 emissions (in thousand metric tons of CO2 equivalent) of 2000 in Hungary to that in Iceland?
Give a very brief answer. 1.41. What is the ratio of the SF6 emissions (in thousand metric tons of CO2 equivalent) in 2005 in Hungary to that in Iceland?
Your answer should be compact. 8.57. What is the ratio of the SF6 emissions (in thousand metric tons of CO2 equivalent) in 2008 in Hungary to that in Iceland?
Provide a succinct answer. 7.22. What is the ratio of the SF6 emissions (in thousand metric tons of CO2 equivalent) of 1990 in Hungary to that in India?
Provide a short and direct response. 0. What is the ratio of the SF6 emissions (in thousand metric tons of CO2 equivalent) of 2000 in Hungary to that in India?
Offer a very short reply. 0.01. What is the ratio of the SF6 emissions (in thousand metric tons of CO2 equivalent) in 2005 in Hungary to that in India?
Offer a very short reply. 0.01. What is the ratio of the SF6 emissions (in thousand metric tons of CO2 equivalent) of 2008 in Hungary to that in India?
Your answer should be very brief. 0.01. What is the ratio of the SF6 emissions (in thousand metric tons of CO2 equivalent) in 1990 in Hungary to that in Indonesia?
Offer a very short reply. 0.02. What is the ratio of the SF6 emissions (in thousand metric tons of CO2 equivalent) of 2000 in Hungary to that in Indonesia?
Your answer should be compact. 0.03. What is the ratio of the SF6 emissions (in thousand metric tons of CO2 equivalent) in 2005 in Hungary to that in Indonesia?
Your response must be concise. 0.03. What is the ratio of the SF6 emissions (in thousand metric tons of CO2 equivalent) of 2008 in Hungary to that in Indonesia?
Provide a short and direct response. 0.03. What is the ratio of the SF6 emissions (in thousand metric tons of CO2 equivalent) of 1990 in Iceland to that in India?
Give a very brief answer. 0. What is the ratio of the SF6 emissions (in thousand metric tons of CO2 equivalent) in 2000 in Iceland to that in India?
Provide a succinct answer. 0.01. What is the ratio of the SF6 emissions (in thousand metric tons of CO2 equivalent) in 2005 in Iceland to that in India?
Ensure brevity in your answer.  0. What is the ratio of the SF6 emissions (in thousand metric tons of CO2 equivalent) in 2008 in Iceland to that in India?
Your response must be concise. 0. What is the ratio of the SF6 emissions (in thousand metric tons of CO2 equivalent) in 1990 in Iceland to that in Indonesia?
Your answer should be very brief. 0. What is the ratio of the SF6 emissions (in thousand metric tons of CO2 equivalent) in 2000 in Iceland to that in Indonesia?
Give a very brief answer. 0.02. What is the ratio of the SF6 emissions (in thousand metric tons of CO2 equivalent) in 2005 in Iceland to that in Indonesia?
Make the answer very short. 0. What is the ratio of the SF6 emissions (in thousand metric tons of CO2 equivalent) of 2008 in Iceland to that in Indonesia?
Provide a succinct answer. 0. What is the ratio of the SF6 emissions (in thousand metric tons of CO2 equivalent) in 1990 in India to that in Indonesia?
Make the answer very short. 5.42. What is the ratio of the SF6 emissions (in thousand metric tons of CO2 equivalent) of 2000 in India to that in Indonesia?
Keep it short and to the point. 4.15. What is the ratio of the SF6 emissions (in thousand metric tons of CO2 equivalent) of 2005 in India to that in Indonesia?
Your answer should be very brief. 5.17. What is the ratio of the SF6 emissions (in thousand metric tons of CO2 equivalent) in 2008 in India to that in Indonesia?
Offer a terse response. 5.22. What is the difference between the highest and the second highest SF6 emissions (in thousand metric tons of CO2 equivalent) in 1990?
Give a very brief answer. 4694.7. What is the difference between the highest and the second highest SF6 emissions (in thousand metric tons of CO2 equivalent) in 2000?
Offer a very short reply. 2607.9. What is the difference between the highest and the second highest SF6 emissions (in thousand metric tons of CO2 equivalent) of 2005?
Make the answer very short. 3692.6. What is the difference between the highest and the second highest SF6 emissions (in thousand metric tons of CO2 equivalent) of 2008?
Keep it short and to the point. 4285. What is the difference between the highest and the lowest SF6 emissions (in thousand metric tons of CO2 equivalent) in 1990?
Provide a short and direct response. 5754. What is the difference between the highest and the lowest SF6 emissions (in thousand metric tons of CO2 equivalent) of 2000?
Give a very brief answer. 3416.8. What is the difference between the highest and the lowest SF6 emissions (in thousand metric tons of CO2 equivalent) of 2005?
Ensure brevity in your answer.  4575.2. What is the difference between the highest and the lowest SF6 emissions (in thousand metric tons of CO2 equivalent) of 2008?
Provide a short and direct response. 5297.4. 